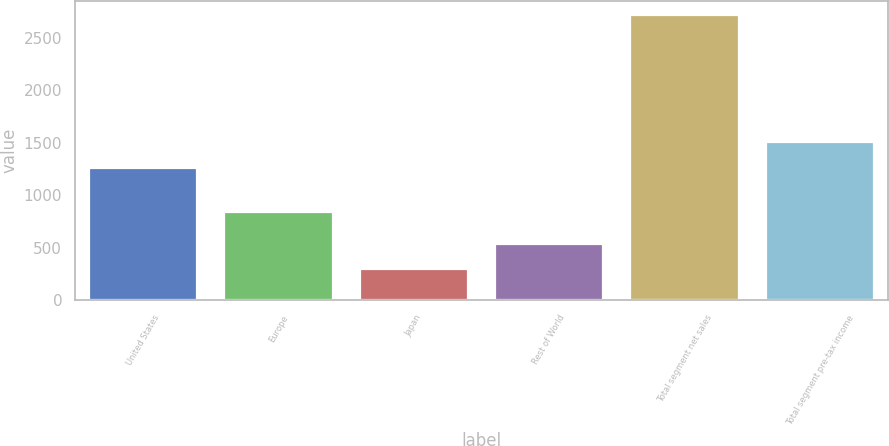<chart> <loc_0><loc_0><loc_500><loc_500><bar_chart><fcel>United States<fcel>Europe<fcel>Japan<fcel>Rest of World<fcel>Total segment net sales<fcel>Total segment pre-tax income<nl><fcel>1262.8<fcel>842.9<fcel>297.2<fcel>539.28<fcel>2718<fcel>1504.88<nl></chart> 